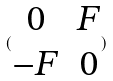<formula> <loc_0><loc_0><loc_500><loc_500>( \begin{matrix} 0 & F \\ - F & 0 \end{matrix} )</formula> 